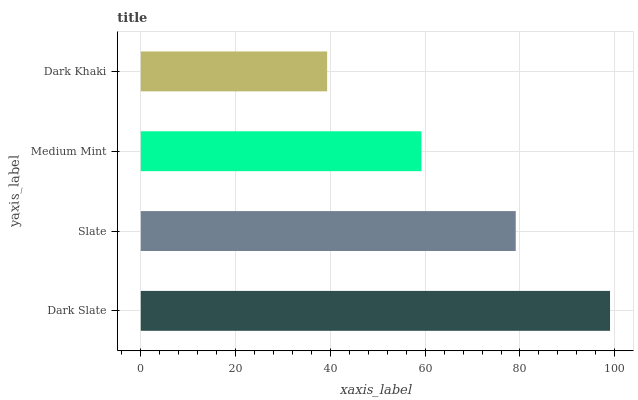Is Dark Khaki the minimum?
Answer yes or no. Yes. Is Dark Slate the maximum?
Answer yes or no. Yes. Is Slate the minimum?
Answer yes or no. No. Is Slate the maximum?
Answer yes or no. No. Is Dark Slate greater than Slate?
Answer yes or no. Yes. Is Slate less than Dark Slate?
Answer yes or no. Yes. Is Slate greater than Dark Slate?
Answer yes or no. No. Is Dark Slate less than Slate?
Answer yes or no. No. Is Slate the high median?
Answer yes or no. Yes. Is Medium Mint the low median?
Answer yes or no. Yes. Is Dark Khaki the high median?
Answer yes or no. No. Is Slate the low median?
Answer yes or no. No. 